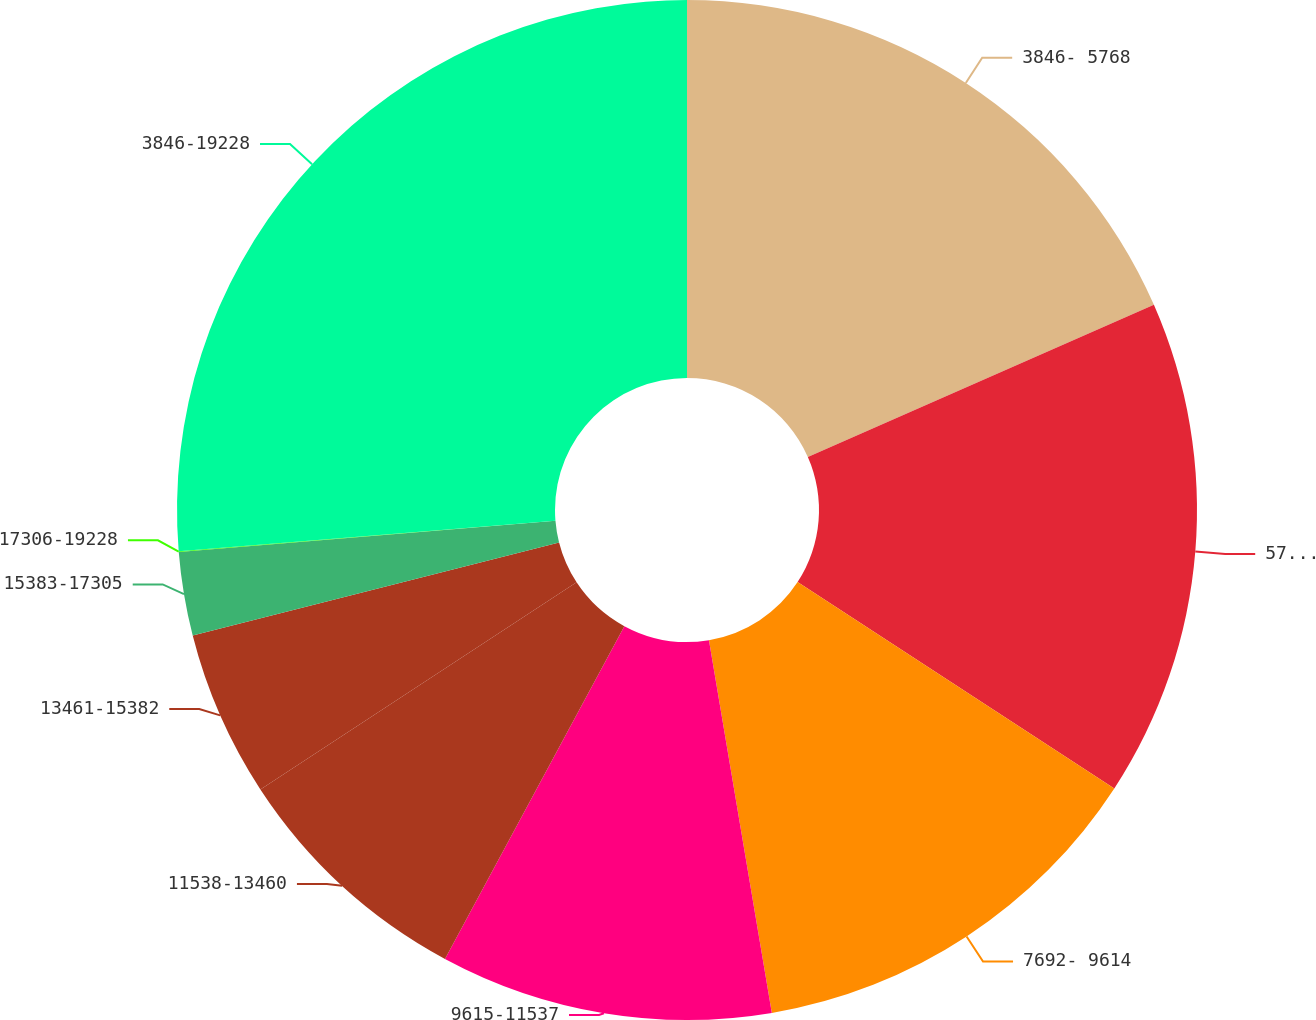<chart> <loc_0><loc_0><loc_500><loc_500><pie_chart><fcel>3846- 5768<fcel>5769- 7691<fcel>7692- 9614<fcel>9615-11537<fcel>11538-13460<fcel>13461-15382<fcel>15383-17305<fcel>17306-19228<fcel>3846-19228<nl><fcel>18.41%<fcel>15.78%<fcel>13.15%<fcel>10.53%<fcel>7.9%<fcel>5.27%<fcel>2.65%<fcel>0.02%<fcel>26.29%<nl></chart> 